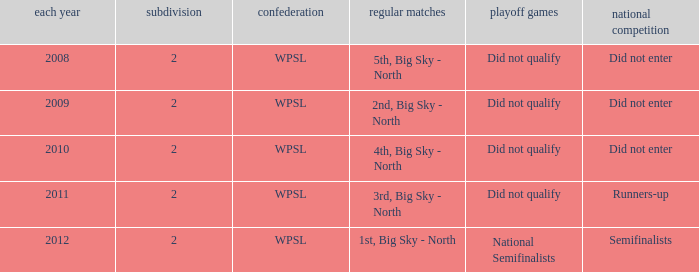What is the highest number of divisions mentioned? 2.0. 